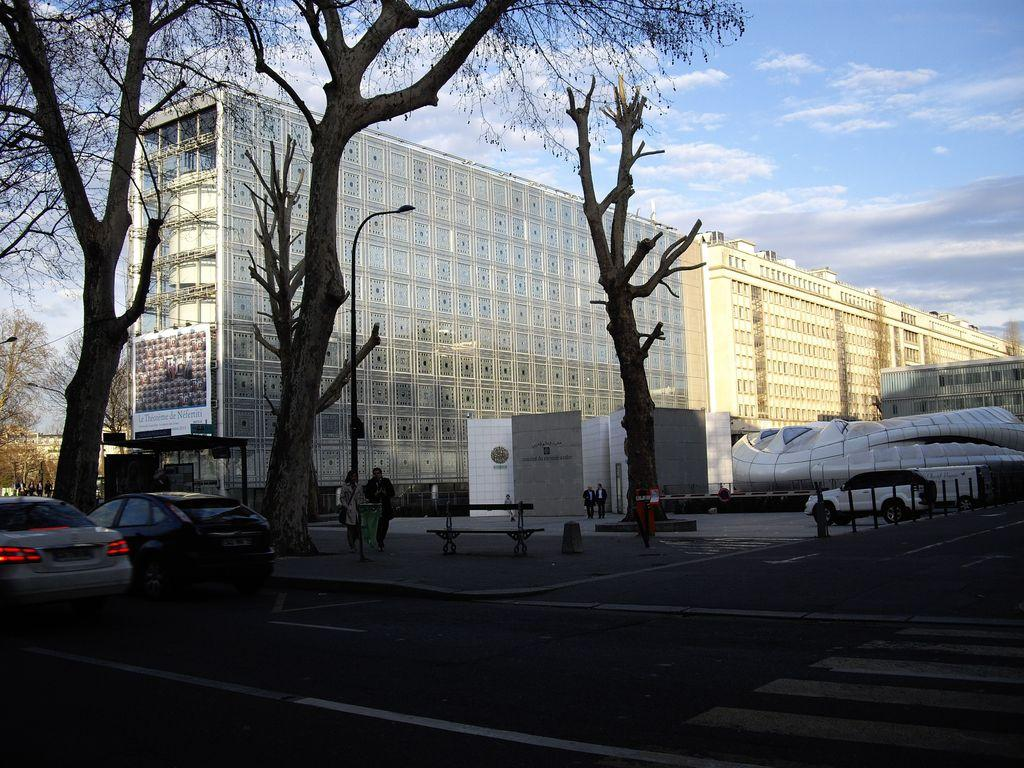What type of structures can be seen in the image? There are buildings in the image. What type of vehicles are present in the image? There are cars in the image. Who or what else can be seen in the image? There are people in the image. What type of lighting is present in the image? There is a street lamp in the image. What type of vegetation is present in the image? There are trees in the image. What part of the natural environment is visible in the image? The sky is visible in the image, and there are clouds present. What type of alarm can be heard going off in the image? There is no alarm present in the image, and therefore no sound can be heard. What type of recess is visible in the image? There is no recess present in the image. 